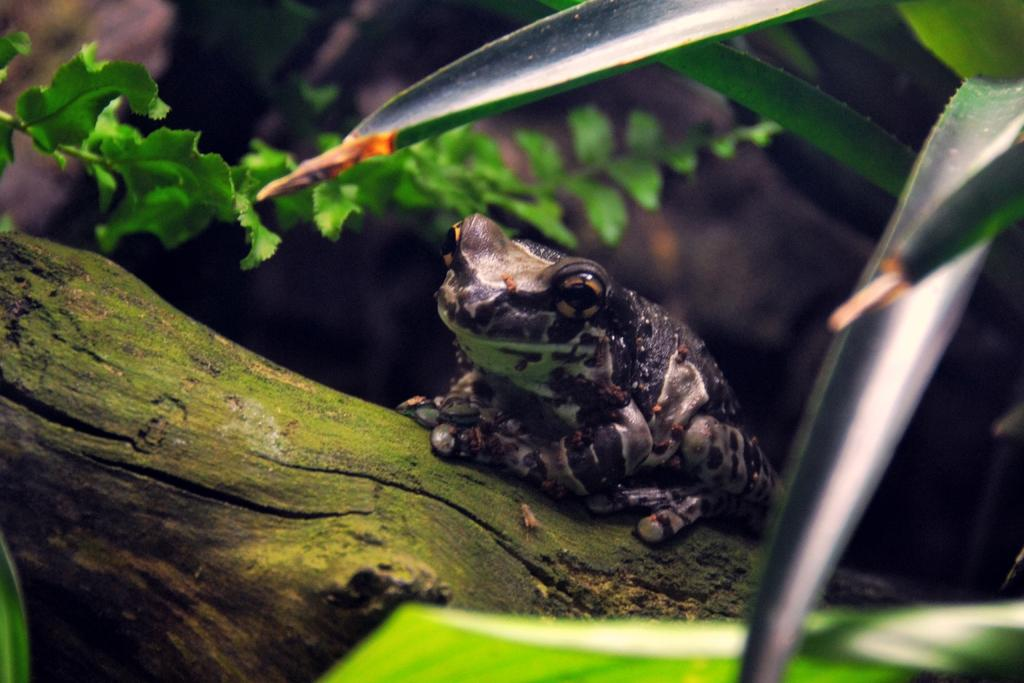What animal is the main subject of the picture? There is a frog in the picture. Where is the frog located in the image? The frog is sitting on a tree trunk. What type of vegetation is present in the picture? There are leaves in the picture. What type of condition do the giants have in the image? There are no giants present in the image, so it is not possible to determine their condition. 